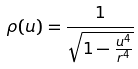<formula> <loc_0><loc_0><loc_500><loc_500>\rho ( u ) = \frac { 1 } { \sqrt { 1 - \frac { u ^ { 4 } } { r ^ { 4 } } } }</formula> 